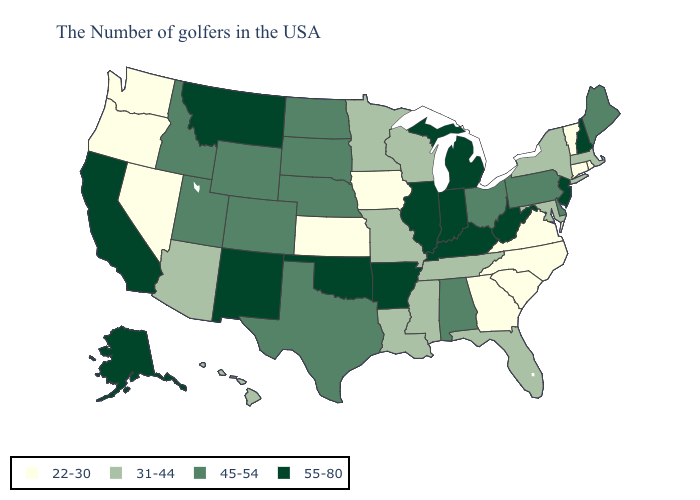Name the states that have a value in the range 55-80?
Concise answer only. New Hampshire, New Jersey, West Virginia, Michigan, Kentucky, Indiana, Illinois, Arkansas, Oklahoma, New Mexico, Montana, California, Alaska. Name the states that have a value in the range 45-54?
Be succinct. Maine, Delaware, Pennsylvania, Ohio, Alabama, Nebraska, Texas, South Dakota, North Dakota, Wyoming, Colorado, Utah, Idaho. Does Michigan have the highest value in the USA?
Answer briefly. Yes. What is the highest value in the MidWest ?
Keep it brief. 55-80. Does West Virginia have the lowest value in the USA?
Write a very short answer. No. Does New York have the lowest value in the USA?
Give a very brief answer. No. What is the value of Wisconsin?
Write a very short answer. 31-44. Does Texas have the lowest value in the USA?
Be succinct. No. Does Connecticut have a lower value than New York?
Answer briefly. Yes. Which states hav the highest value in the West?
Be succinct. New Mexico, Montana, California, Alaska. What is the value of Maryland?
Concise answer only. 31-44. Does New Jersey have the same value as South Carolina?
Be succinct. No. What is the highest value in the USA?
Answer briefly. 55-80. Does the first symbol in the legend represent the smallest category?
Be succinct. Yes. What is the value of New York?
Answer briefly. 31-44. 